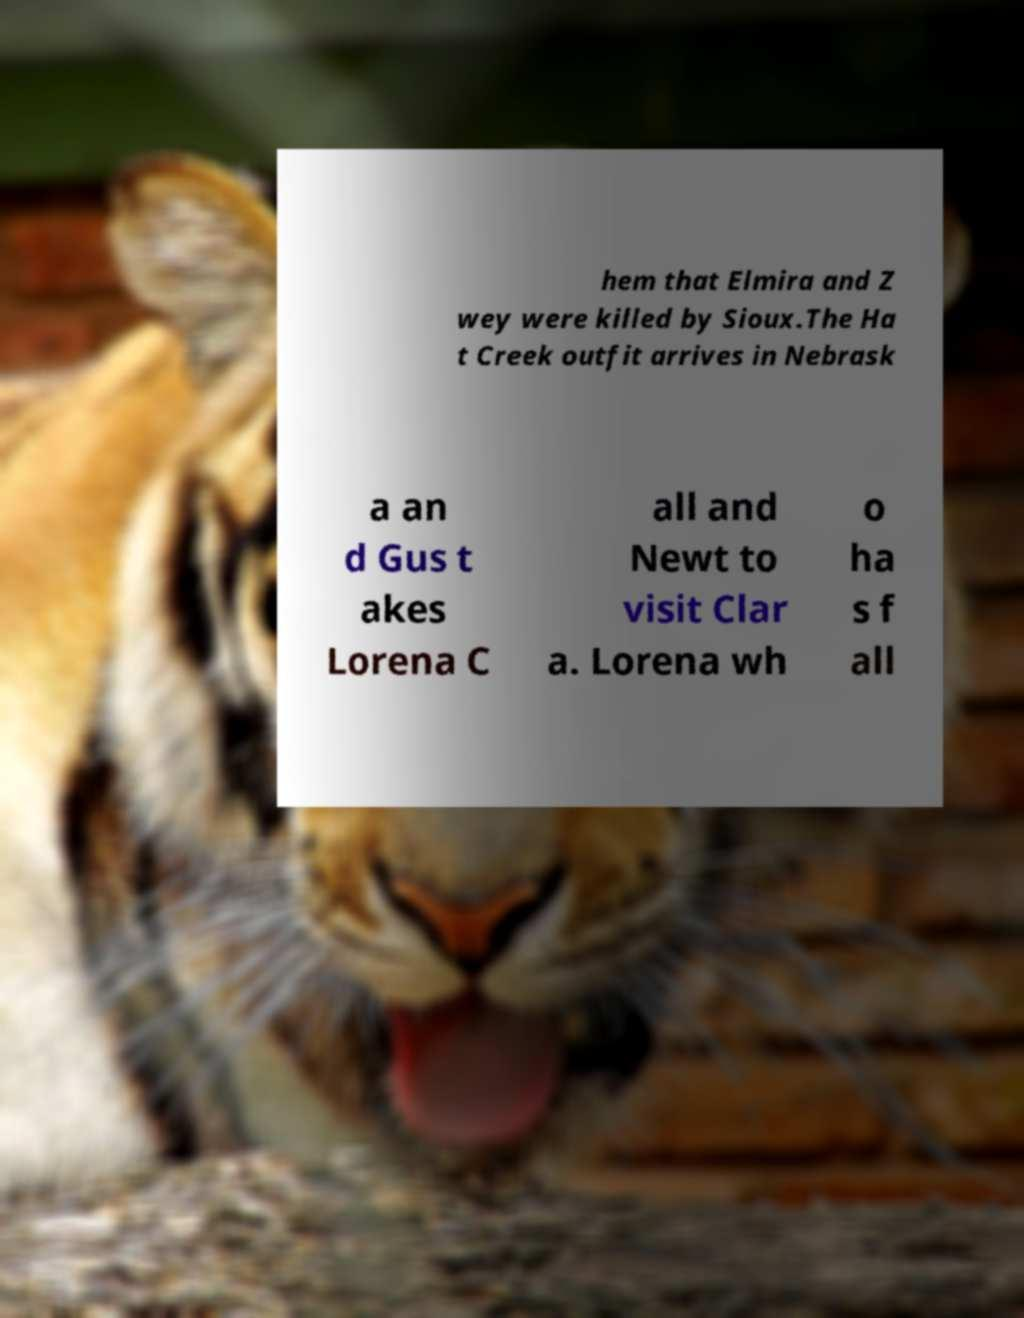Can you read and provide the text displayed in the image?This photo seems to have some interesting text. Can you extract and type it out for me? hem that Elmira and Z wey were killed by Sioux.The Ha t Creek outfit arrives in Nebrask a an d Gus t akes Lorena C all and Newt to visit Clar a. Lorena wh o ha s f all 